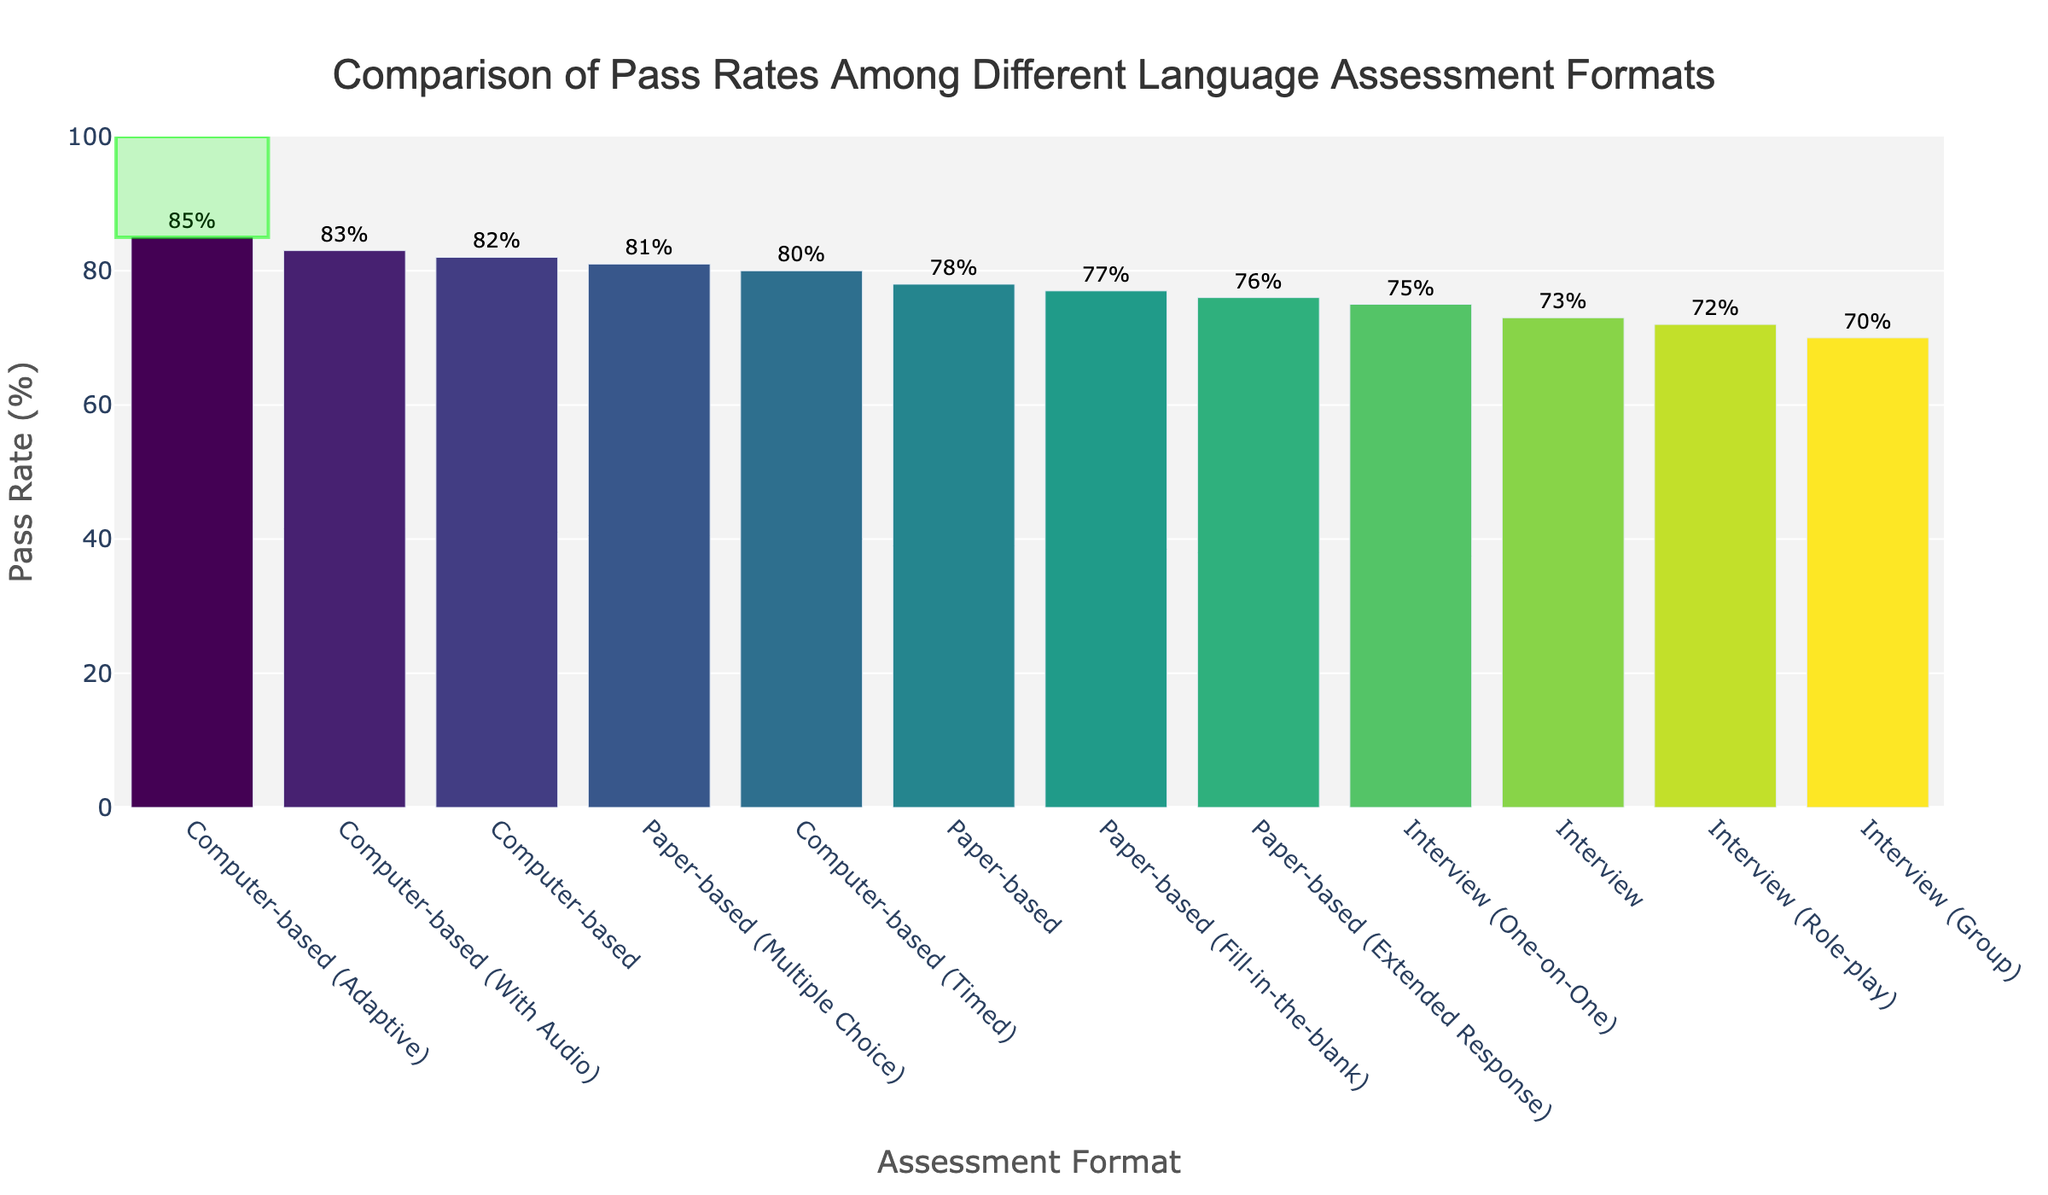what is the pass rate for the computer-based format? Locate the bar labeled "Computer-based," which has a text label indicating the pass rate.
Answer: 82% which format has the highest pass rate? Locate the tallest bar in the chart and refer to its label. The text label gives the pass rate.
Answer: Computer-based (Adaptive) what is the difference in pass rates between the highest and lowest performing formats? Identify the pass rates of the highest (85%, Computer-based (Adaptive)) and lowest (70%, Interview (Group)) performing formats and calculate the difference: 85 - 70 = 15
Answer: 15% what is the average pass rate across all formats? Add all the pass rates and divide by the number of formats: (82 + 78 + 73 + 85 + 76 + 70 + 80 + 81 + 75 + 83 + 77 + 72) / 12 = 870 / 12 = 72.5
Answer: 72.5% which format has a pass rate closest to the average pass rate? Compare each pass rate to the average (72.5%) and find the closest one: Computer-based (With Audio) = 83%, Paper-based (Fill-in-the-blank) = 77%
Answer: Paper-based (Fill-in-the-blank) how many formats have a pass rate above 80%? Identify all bar heights greater than 80%: Computer-based (82%), Computer-based (Adaptive) (85%), Computer-based (Timed) (80%), Computer-based (With Audio) (83%), Paper-based (Multiple Choice) (81%)
Answer: 5 is there a format whose pass rate is exactly equal to 75%? Locate any bar with a text label of 75%: Interview (One-on-One).
Answer: Yes which format's pass rate is 11% higher than the pass rate of Interview (Role-play)? Calculate 72% + 11% = 83%, and find the format with a pass rate of 83%: Computer-based (With Audio)
Answer: Computer-based (With Audio) what is the median pass rate of the formats? Order the pass rates and find the middle one(s): {70, 72, 73, 75, 76, 77, 78, 80, 81, 82, 83, 85}. The median is the average of the 6th and 7th values: (77 + 78) / 2
Answer: 77.5% which group has a higher pass rate: paper-based or interview-based formats? Calculate the average pass rate for each group:
Paper-based: (78 + 76 + 81 + 77) / 4 = 78%
Interview-based: (73 + 70 + 75 + 72) / 4 = 72.5%
Answer: Paper-based 